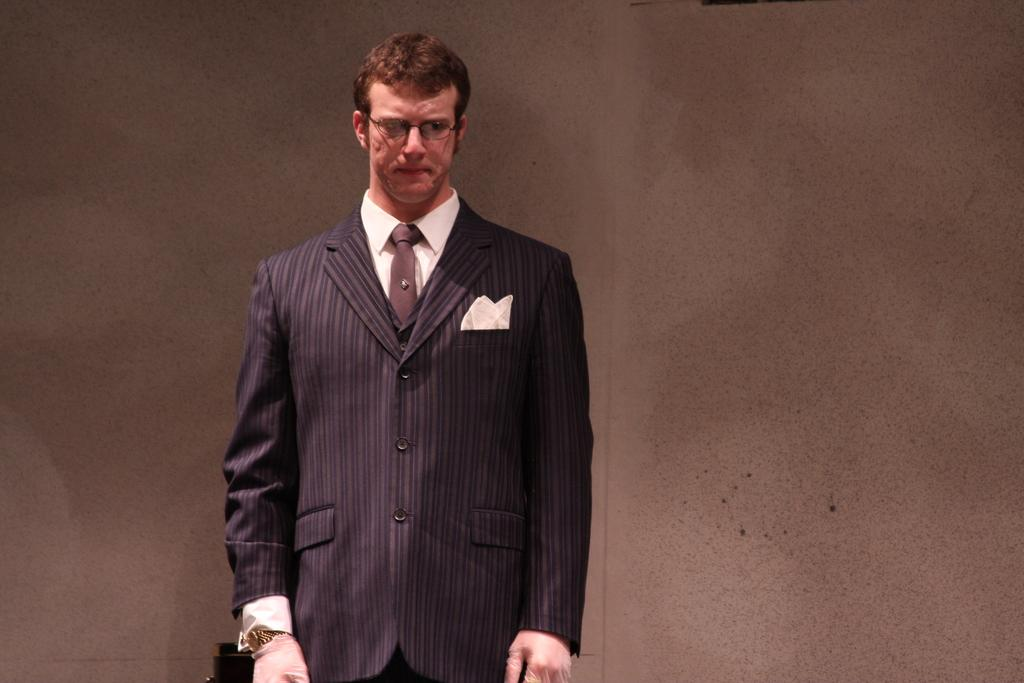What is the main subject of the image? There is a person standing in the image. What is the person wearing on their upper body? The person is wearing a black blazer and a white shirt. What color is the tie the person is wearing? The person is wearing a brown color tie. What can be seen in the background of the image? The background of the image is brown in color. What type of bed can be seen in the image? There is no bed present in the image; it features a person standing and wearing specific clothing. How does the person's stomach look in the image? The image does not provide any information about the person's stomach, as it focuses on their upper body clothing. 